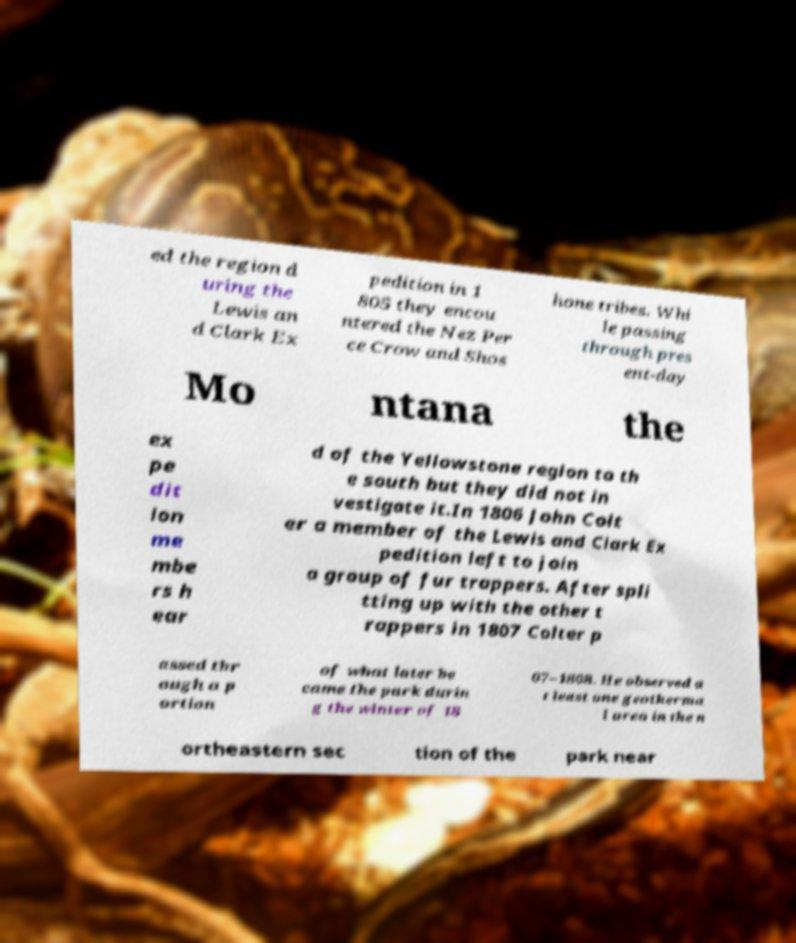What messages or text are displayed in this image? I need them in a readable, typed format. ed the region d uring the Lewis an d Clark Ex pedition in 1 805 they encou ntered the Nez Per ce Crow and Shos hone tribes. Whi le passing through pres ent-day Mo ntana the ex pe dit ion me mbe rs h ear d of the Yellowstone region to th e south but they did not in vestigate it.In 1806 John Colt er a member of the Lewis and Clark Ex pedition left to join a group of fur trappers. After spli tting up with the other t rappers in 1807 Colter p assed thr ough a p ortion of what later be came the park durin g the winter of 18 07–1808. He observed a t least one geotherma l area in the n ortheastern sec tion of the park near 